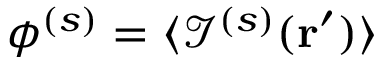<formula> <loc_0><loc_0><loc_500><loc_500>\phi ^ { ( s ) } = \langle \mathcal { I } ^ { ( s ) } ( r ^ { \prime } ) \rangle</formula> 